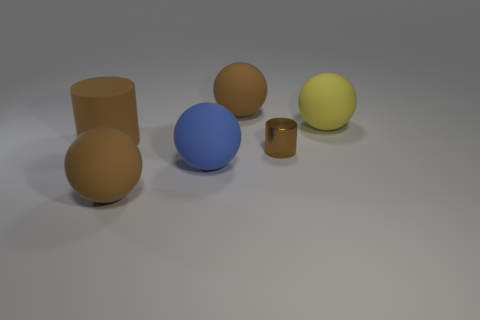Subtract all yellow balls. How many balls are left? 3 Subtract all blue balls. How many balls are left? 3 Subtract 3 balls. How many balls are left? 1 Add 1 brown shiny objects. How many objects exist? 7 Subtract all green cylinders. How many blue spheres are left? 1 Add 4 rubber objects. How many rubber objects are left? 9 Add 2 small brown objects. How many small brown objects exist? 3 Subtract 1 yellow balls. How many objects are left? 5 Subtract all balls. How many objects are left? 2 Subtract all gray balls. Subtract all gray cylinders. How many balls are left? 4 